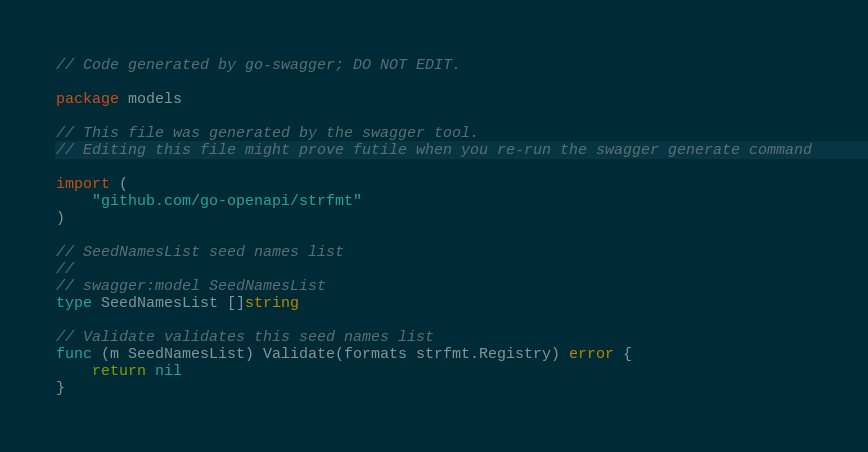Convert code to text. <code><loc_0><loc_0><loc_500><loc_500><_Go_>// Code generated by go-swagger; DO NOT EDIT.

package models

// This file was generated by the swagger tool.
// Editing this file might prove futile when you re-run the swagger generate command

import (
	"github.com/go-openapi/strfmt"
)

// SeedNamesList seed names list
//
// swagger:model SeedNamesList
type SeedNamesList []string

// Validate validates this seed names list
func (m SeedNamesList) Validate(formats strfmt.Registry) error {
	return nil
}
</code> 